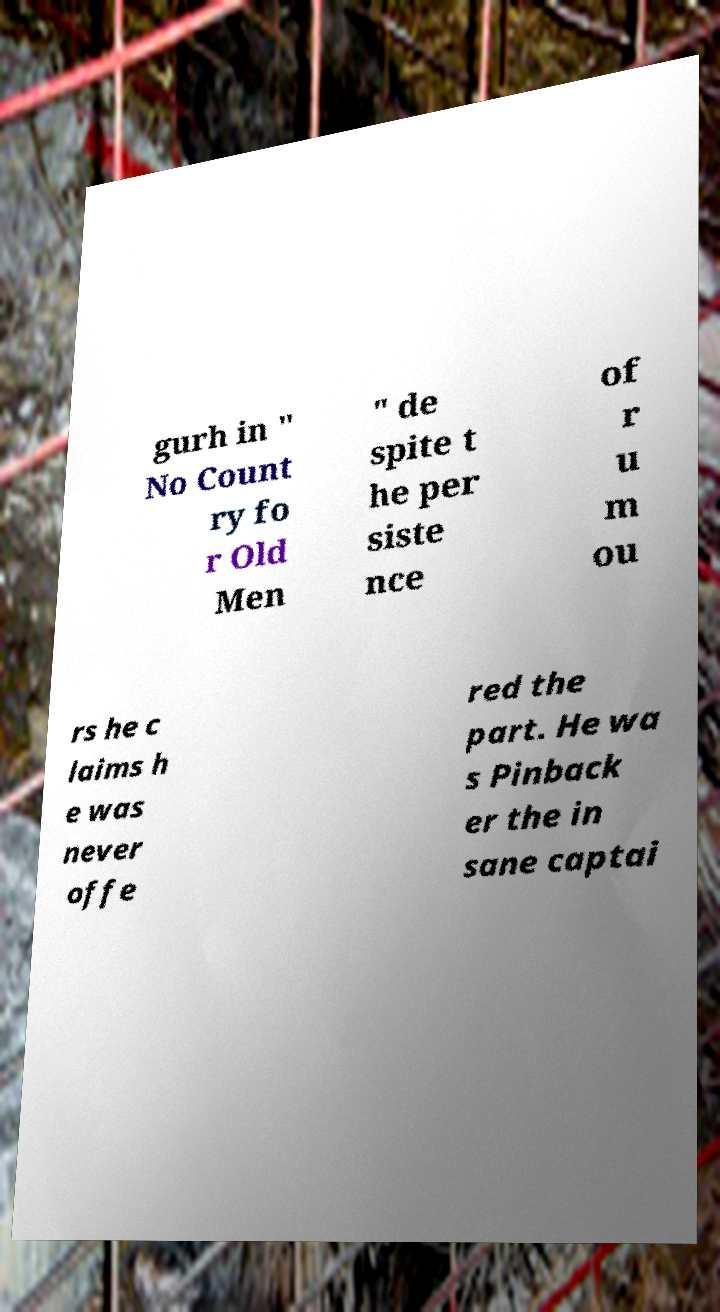What messages or text are displayed in this image? I need them in a readable, typed format. gurh in " No Count ry fo r Old Men " de spite t he per siste nce of r u m ou rs he c laims h e was never offe red the part. He wa s Pinback er the in sane captai 